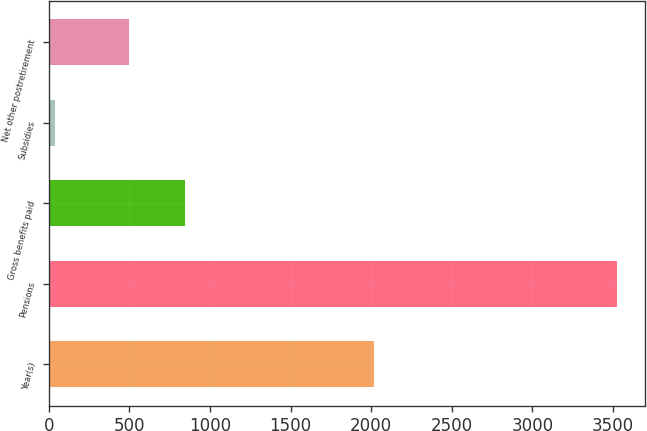Convert chart to OTSL. <chart><loc_0><loc_0><loc_500><loc_500><bar_chart><fcel>Year(s)<fcel>Pensions<fcel>Gross benefits paid<fcel>Subsidies<fcel>Net other postretirement<nl><fcel>2016<fcel>3522<fcel>846.1<fcel>41<fcel>498<nl></chart> 